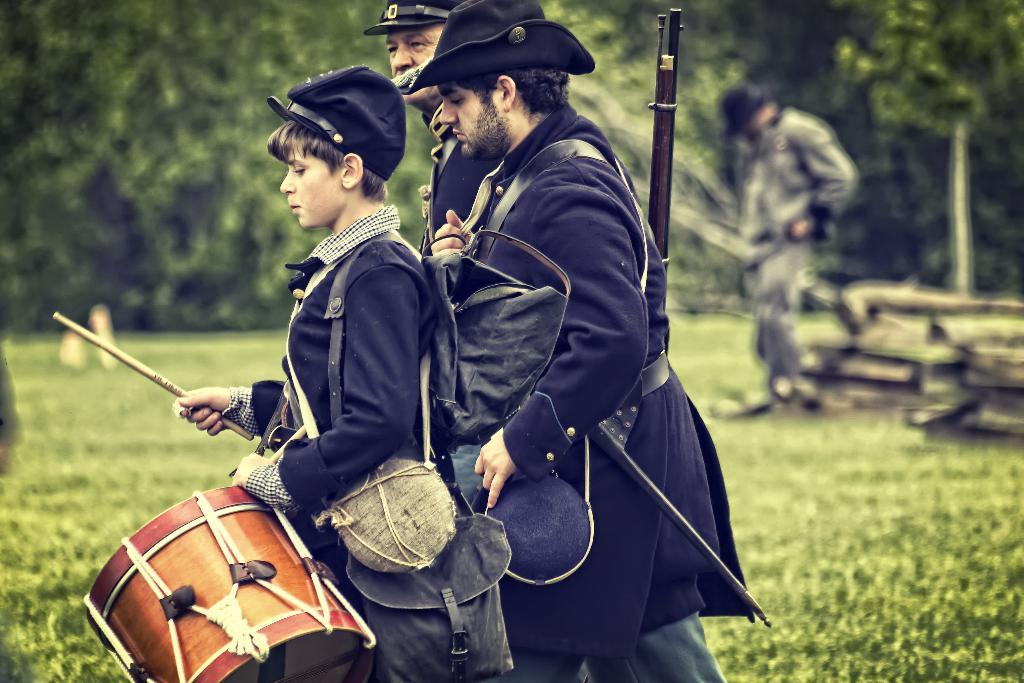How many people are in the image? There are three people in the image: two men and one woman. What are the individuals holding in their hands? The individuals are holding drumsticks and caps. What can be seen in the background of the image? There are trees, people, grass, and wooden sticks in the background of the image. What type of scientific experiment is being conducted in the image? There is no indication of a scientific experiment being conducted in the image. How many sheep are present in the image? There are no sheep present in the image. 